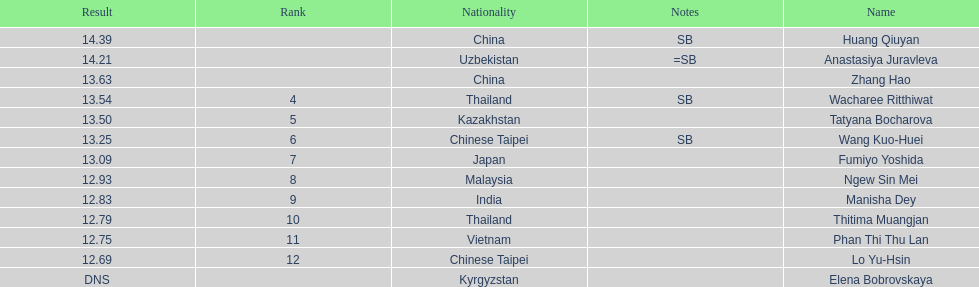What was the number of athletes representing china? 2. 